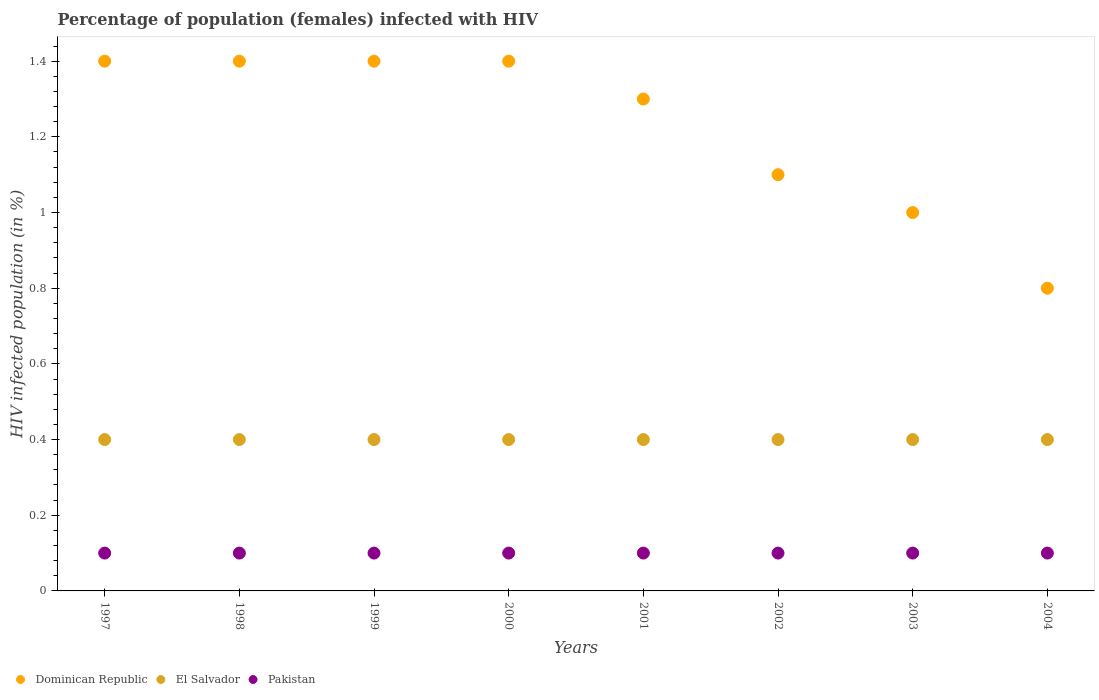How many different coloured dotlines are there?
Your response must be concise. 3. What is the percentage of HIV infected female population in Pakistan in 2000?
Provide a succinct answer. 0.1. Across all years, what is the maximum percentage of HIV infected female population in Pakistan?
Provide a succinct answer. 0.1. What is the total percentage of HIV infected female population in Pakistan in the graph?
Offer a very short reply. 0.8. What is the difference between the percentage of HIV infected female population in Dominican Republic in 1998 and that in 2001?
Provide a succinct answer. 0.1. What is the difference between the percentage of HIV infected female population in El Salvador in 1999 and the percentage of HIV infected female population in Dominican Republic in 2000?
Offer a terse response. -1. What is the average percentage of HIV infected female population in Dominican Republic per year?
Your response must be concise. 1.23. In the year 2003, what is the difference between the percentage of HIV infected female population in El Salvador and percentage of HIV infected female population in Pakistan?
Give a very brief answer. 0.3. What is the ratio of the percentage of HIV infected female population in Dominican Republic in 1998 to that in 2000?
Make the answer very short. 1. Is the percentage of HIV infected female population in Dominican Republic in 2001 less than that in 2002?
Your response must be concise. No. Is the difference between the percentage of HIV infected female population in El Salvador in 1999 and 2003 greater than the difference between the percentage of HIV infected female population in Pakistan in 1999 and 2003?
Provide a short and direct response. No. What is the difference between the highest and the second highest percentage of HIV infected female population in Pakistan?
Offer a very short reply. 0. What is the difference between the highest and the lowest percentage of HIV infected female population in Dominican Republic?
Give a very brief answer. 0.6. How many years are there in the graph?
Make the answer very short. 8. What is the difference between two consecutive major ticks on the Y-axis?
Your answer should be compact. 0.2. Does the graph contain any zero values?
Ensure brevity in your answer.  No. Does the graph contain grids?
Your response must be concise. No. Where does the legend appear in the graph?
Your response must be concise. Bottom left. How many legend labels are there?
Your response must be concise. 3. What is the title of the graph?
Offer a terse response. Percentage of population (females) infected with HIV. What is the label or title of the Y-axis?
Keep it short and to the point. HIV infected population (in %). What is the HIV infected population (in %) in El Salvador in 1997?
Provide a succinct answer. 0.4. What is the HIV infected population (in %) in Pakistan in 1997?
Give a very brief answer. 0.1. What is the HIV infected population (in %) in El Salvador in 1998?
Provide a succinct answer. 0.4. What is the HIV infected population (in %) of Pakistan in 1998?
Give a very brief answer. 0.1. What is the HIV infected population (in %) of El Salvador in 1999?
Make the answer very short. 0.4. What is the HIV infected population (in %) in Dominican Republic in 2000?
Provide a succinct answer. 1.4. What is the HIV infected population (in %) of Pakistan in 2000?
Provide a short and direct response. 0.1. What is the HIV infected population (in %) of Dominican Republic in 2002?
Offer a terse response. 1.1. What is the HIV infected population (in %) of El Salvador in 2002?
Your answer should be very brief. 0.4. What is the HIV infected population (in %) of Pakistan in 2002?
Make the answer very short. 0.1. What is the HIV infected population (in %) in Dominican Republic in 2003?
Your response must be concise. 1. What is the HIV infected population (in %) of Dominican Republic in 2004?
Your answer should be compact. 0.8. Across all years, what is the maximum HIV infected population (in %) in Dominican Republic?
Offer a terse response. 1.4. Across all years, what is the maximum HIV infected population (in %) of Pakistan?
Your response must be concise. 0.1. Across all years, what is the minimum HIV infected population (in %) of Dominican Republic?
Provide a succinct answer. 0.8. Across all years, what is the minimum HIV infected population (in %) of El Salvador?
Provide a succinct answer. 0.4. What is the total HIV infected population (in %) of Dominican Republic in the graph?
Provide a short and direct response. 9.8. What is the difference between the HIV infected population (in %) in Dominican Republic in 1997 and that in 1999?
Offer a terse response. 0. What is the difference between the HIV infected population (in %) in Dominican Republic in 1997 and that in 2000?
Offer a terse response. 0. What is the difference between the HIV infected population (in %) of Dominican Republic in 1997 and that in 2001?
Ensure brevity in your answer.  0.1. What is the difference between the HIV infected population (in %) in El Salvador in 1997 and that in 2001?
Keep it short and to the point. 0. What is the difference between the HIV infected population (in %) of Pakistan in 1997 and that in 2001?
Make the answer very short. 0. What is the difference between the HIV infected population (in %) of El Salvador in 1997 and that in 2002?
Your answer should be very brief. 0. What is the difference between the HIV infected population (in %) of El Salvador in 1997 and that in 2003?
Make the answer very short. 0. What is the difference between the HIV infected population (in %) in Pakistan in 1997 and that in 2003?
Your answer should be very brief. 0. What is the difference between the HIV infected population (in %) in Dominican Republic in 1997 and that in 2004?
Provide a succinct answer. 0.6. What is the difference between the HIV infected population (in %) of El Salvador in 1997 and that in 2004?
Offer a terse response. 0. What is the difference between the HIV infected population (in %) in El Salvador in 1998 and that in 1999?
Give a very brief answer. 0. What is the difference between the HIV infected population (in %) in Pakistan in 1998 and that in 1999?
Make the answer very short. 0. What is the difference between the HIV infected population (in %) of El Salvador in 1998 and that in 2000?
Make the answer very short. 0. What is the difference between the HIV infected population (in %) of Pakistan in 1998 and that in 2000?
Offer a terse response. 0. What is the difference between the HIV infected population (in %) of Pakistan in 1998 and that in 2001?
Offer a very short reply. 0. What is the difference between the HIV infected population (in %) of Dominican Republic in 1998 and that in 2002?
Provide a succinct answer. 0.3. What is the difference between the HIV infected population (in %) of El Salvador in 1998 and that in 2002?
Keep it short and to the point. 0. What is the difference between the HIV infected population (in %) of Dominican Republic in 1998 and that in 2003?
Offer a terse response. 0.4. What is the difference between the HIV infected population (in %) in El Salvador in 1998 and that in 2003?
Make the answer very short. 0. What is the difference between the HIV infected population (in %) in Pakistan in 1998 and that in 2003?
Your answer should be compact. 0. What is the difference between the HIV infected population (in %) in El Salvador in 1998 and that in 2004?
Keep it short and to the point. 0. What is the difference between the HIV infected population (in %) of Pakistan in 1998 and that in 2004?
Offer a very short reply. 0. What is the difference between the HIV infected population (in %) in Dominican Republic in 1999 and that in 2000?
Make the answer very short. 0. What is the difference between the HIV infected population (in %) in Pakistan in 1999 and that in 2000?
Your response must be concise. 0. What is the difference between the HIV infected population (in %) in Dominican Republic in 1999 and that in 2001?
Offer a terse response. 0.1. What is the difference between the HIV infected population (in %) in El Salvador in 1999 and that in 2001?
Your answer should be very brief. 0. What is the difference between the HIV infected population (in %) in Dominican Republic in 1999 and that in 2003?
Offer a very short reply. 0.4. What is the difference between the HIV infected population (in %) in Pakistan in 1999 and that in 2003?
Make the answer very short. 0. What is the difference between the HIV infected population (in %) in Pakistan in 1999 and that in 2004?
Provide a succinct answer. 0. What is the difference between the HIV infected population (in %) in Dominican Republic in 2000 and that in 2001?
Provide a short and direct response. 0.1. What is the difference between the HIV infected population (in %) in Dominican Republic in 2000 and that in 2002?
Provide a succinct answer. 0.3. What is the difference between the HIV infected population (in %) of El Salvador in 2000 and that in 2002?
Keep it short and to the point. 0. What is the difference between the HIV infected population (in %) in El Salvador in 2000 and that in 2003?
Make the answer very short. 0. What is the difference between the HIV infected population (in %) in Pakistan in 2000 and that in 2003?
Your answer should be very brief. 0. What is the difference between the HIV infected population (in %) of Dominican Republic in 2000 and that in 2004?
Offer a terse response. 0.6. What is the difference between the HIV infected population (in %) of Pakistan in 2000 and that in 2004?
Your response must be concise. 0. What is the difference between the HIV infected population (in %) of Dominican Republic in 2001 and that in 2002?
Keep it short and to the point. 0.2. What is the difference between the HIV infected population (in %) in El Salvador in 2001 and that in 2003?
Make the answer very short. 0. What is the difference between the HIV infected population (in %) in Dominican Republic in 2001 and that in 2004?
Ensure brevity in your answer.  0.5. What is the difference between the HIV infected population (in %) of El Salvador in 2001 and that in 2004?
Your answer should be very brief. 0. What is the difference between the HIV infected population (in %) in Dominican Republic in 2002 and that in 2003?
Your response must be concise. 0.1. What is the difference between the HIV infected population (in %) in El Salvador in 2002 and that in 2003?
Offer a very short reply. 0. What is the difference between the HIV infected population (in %) in Pakistan in 2002 and that in 2003?
Offer a very short reply. 0. What is the difference between the HIV infected population (in %) in Dominican Republic in 2003 and that in 2004?
Make the answer very short. 0.2. What is the difference between the HIV infected population (in %) in El Salvador in 2003 and that in 2004?
Your response must be concise. 0. What is the difference between the HIV infected population (in %) of Pakistan in 2003 and that in 2004?
Provide a succinct answer. 0. What is the difference between the HIV infected population (in %) of Dominican Republic in 1997 and the HIV infected population (in %) of El Salvador in 1998?
Keep it short and to the point. 1. What is the difference between the HIV infected population (in %) in Dominican Republic in 1997 and the HIV infected population (in %) in Pakistan in 1998?
Provide a succinct answer. 1.3. What is the difference between the HIV infected population (in %) of Dominican Republic in 1997 and the HIV infected population (in %) of El Salvador in 1999?
Your answer should be very brief. 1. What is the difference between the HIV infected population (in %) of Dominican Republic in 1997 and the HIV infected population (in %) of Pakistan in 1999?
Your response must be concise. 1.3. What is the difference between the HIV infected population (in %) of El Salvador in 1997 and the HIV infected population (in %) of Pakistan in 2000?
Your response must be concise. 0.3. What is the difference between the HIV infected population (in %) in Dominican Republic in 1997 and the HIV infected population (in %) in El Salvador in 2001?
Your answer should be very brief. 1. What is the difference between the HIV infected population (in %) in Dominican Republic in 1997 and the HIV infected population (in %) in Pakistan in 2001?
Keep it short and to the point. 1.3. What is the difference between the HIV infected population (in %) of El Salvador in 1997 and the HIV infected population (in %) of Pakistan in 2001?
Ensure brevity in your answer.  0.3. What is the difference between the HIV infected population (in %) of Dominican Republic in 1997 and the HIV infected population (in %) of El Salvador in 2002?
Your answer should be compact. 1. What is the difference between the HIV infected population (in %) of El Salvador in 1997 and the HIV infected population (in %) of Pakistan in 2002?
Your answer should be compact. 0.3. What is the difference between the HIV infected population (in %) in Dominican Republic in 1997 and the HIV infected population (in %) in El Salvador in 2003?
Ensure brevity in your answer.  1. What is the difference between the HIV infected population (in %) of El Salvador in 1997 and the HIV infected population (in %) of Pakistan in 2003?
Your answer should be very brief. 0.3. What is the difference between the HIV infected population (in %) of Dominican Republic in 1997 and the HIV infected population (in %) of Pakistan in 2004?
Offer a terse response. 1.3. What is the difference between the HIV infected population (in %) in El Salvador in 1997 and the HIV infected population (in %) in Pakistan in 2004?
Your answer should be very brief. 0.3. What is the difference between the HIV infected population (in %) of Dominican Republic in 1998 and the HIV infected population (in %) of Pakistan in 2001?
Keep it short and to the point. 1.3. What is the difference between the HIV infected population (in %) of Dominican Republic in 1998 and the HIV infected population (in %) of El Salvador in 2002?
Give a very brief answer. 1. What is the difference between the HIV infected population (in %) of Dominican Republic in 1998 and the HIV infected population (in %) of Pakistan in 2002?
Keep it short and to the point. 1.3. What is the difference between the HIV infected population (in %) of Dominican Republic in 1998 and the HIV infected population (in %) of El Salvador in 2003?
Ensure brevity in your answer.  1. What is the difference between the HIV infected population (in %) of El Salvador in 1998 and the HIV infected population (in %) of Pakistan in 2003?
Your response must be concise. 0.3. What is the difference between the HIV infected population (in %) in El Salvador in 1998 and the HIV infected population (in %) in Pakistan in 2004?
Provide a short and direct response. 0.3. What is the difference between the HIV infected population (in %) in Dominican Republic in 1999 and the HIV infected population (in %) in El Salvador in 2000?
Keep it short and to the point. 1. What is the difference between the HIV infected population (in %) in Dominican Republic in 1999 and the HIV infected population (in %) in El Salvador in 2001?
Provide a succinct answer. 1. What is the difference between the HIV infected population (in %) of Dominican Republic in 1999 and the HIV infected population (in %) of Pakistan in 2001?
Your answer should be very brief. 1.3. What is the difference between the HIV infected population (in %) in El Salvador in 1999 and the HIV infected population (in %) in Pakistan in 2001?
Give a very brief answer. 0.3. What is the difference between the HIV infected population (in %) of Dominican Republic in 1999 and the HIV infected population (in %) of El Salvador in 2002?
Provide a succinct answer. 1. What is the difference between the HIV infected population (in %) in El Salvador in 1999 and the HIV infected population (in %) in Pakistan in 2002?
Offer a very short reply. 0.3. What is the difference between the HIV infected population (in %) in El Salvador in 1999 and the HIV infected population (in %) in Pakistan in 2003?
Your answer should be very brief. 0.3. What is the difference between the HIV infected population (in %) of Dominican Republic in 1999 and the HIV infected population (in %) of El Salvador in 2004?
Your answer should be very brief. 1. What is the difference between the HIV infected population (in %) in El Salvador in 1999 and the HIV infected population (in %) in Pakistan in 2004?
Provide a succinct answer. 0.3. What is the difference between the HIV infected population (in %) of El Salvador in 2000 and the HIV infected population (in %) of Pakistan in 2001?
Offer a very short reply. 0.3. What is the difference between the HIV infected population (in %) of Dominican Republic in 2000 and the HIV infected population (in %) of El Salvador in 2002?
Give a very brief answer. 1. What is the difference between the HIV infected population (in %) in Dominican Republic in 2000 and the HIV infected population (in %) in Pakistan in 2002?
Your answer should be compact. 1.3. What is the difference between the HIV infected population (in %) of Dominican Republic in 2000 and the HIV infected population (in %) of El Salvador in 2003?
Give a very brief answer. 1. What is the difference between the HIV infected population (in %) of El Salvador in 2000 and the HIV infected population (in %) of Pakistan in 2003?
Your answer should be very brief. 0.3. What is the difference between the HIV infected population (in %) in Dominican Republic in 2000 and the HIV infected population (in %) in El Salvador in 2004?
Provide a succinct answer. 1. What is the difference between the HIV infected population (in %) of Dominican Republic in 2000 and the HIV infected population (in %) of Pakistan in 2004?
Keep it short and to the point. 1.3. What is the difference between the HIV infected population (in %) of Dominican Republic in 2001 and the HIV infected population (in %) of Pakistan in 2002?
Your response must be concise. 1.2. What is the difference between the HIV infected population (in %) in El Salvador in 2001 and the HIV infected population (in %) in Pakistan in 2002?
Ensure brevity in your answer.  0.3. What is the difference between the HIV infected population (in %) of Dominican Republic in 2001 and the HIV infected population (in %) of El Salvador in 2004?
Ensure brevity in your answer.  0.9. What is the difference between the HIV infected population (in %) of El Salvador in 2001 and the HIV infected population (in %) of Pakistan in 2004?
Make the answer very short. 0.3. What is the difference between the HIV infected population (in %) of Dominican Republic in 2002 and the HIV infected population (in %) of El Salvador in 2003?
Ensure brevity in your answer.  0.7. What is the difference between the HIV infected population (in %) of Dominican Republic in 2002 and the HIV infected population (in %) of Pakistan in 2003?
Give a very brief answer. 1. What is the difference between the HIV infected population (in %) of El Salvador in 2002 and the HIV infected population (in %) of Pakistan in 2004?
Give a very brief answer. 0.3. What is the difference between the HIV infected population (in %) of El Salvador in 2003 and the HIV infected population (in %) of Pakistan in 2004?
Ensure brevity in your answer.  0.3. What is the average HIV infected population (in %) of Dominican Republic per year?
Make the answer very short. 1.23. What is the average HIV infected population (in %) in El Salvador per year?
Offer a very short reply. 0.4. In the year 1997, what is the difference between the HIV infected population (in %) in Dominican Republic and HIV infected population (in %) in Pakistan?
Offer a very short reply. 1.3. In the year 1998, what is the difference between the HIV infected population (in %) of Dominican Republic and HIV infected population (in %) of El Salvador?
Offer a terse response. 1. In the year 1998, what is the difference between the HIV infected population (in %) in Dominican Republic and HIV infected population (in %) in Pakistan?
Your response must be concise. 1.3. In the year 1998, what is the difference between the HIV infected population (in %) of El Salvador and HIV infected population (in %) of Pakistan?
Make the answer very short. 0.3. In the year 1999, what is the difference between the HIV infected population (in %) of Dominican Republic and HIV infected population (in %) of Pakistan?
Offer a terse response. 1.3. In the year 1999, what is the difference between the HIV infected population (in %) in El Salvador and HIV infected population (in %) in Pakistan?
Provide a short and direct response. 0.3. In the year 2000, what is the difference between the HIV infected population (in %) of Dominican Republic and HIV infected population (in %) of Pakistan?
Keep it short and to the point. 1.3. In the year 2000, what is the difference between the HIV infected population (in %) of El Salvador and HIV infected population (in %) of Pakistan?
Ensure brevity in your answer.  0.3. In the year 2001, what is the difference between the HIV infected population (in %) of Dominican Republic and HIV infected population (in %) of El Salvador?
Provide a succinct answer. 0.9. In the year 2001, what is the difference between the HIV infected population (in %) in El Salvador and HIV infected population (in %) in Pakistan?
Offer a terse response. 0.3. In the year 2002, what is the difference between the HIV infected population (in %) in Dominican Republic and HIV infected population (in %) in El Salvador?
Keep it short and to the point. 0.7. In the year 2002, what is the difference between the HIV infected population (in %) of El Salvador and HIV infected population (in %) of Pakistan?
Keep it short and to the point. 0.3. In the year 2003, what is the difference between the HIV infected population (in %) of El Salvador and HIV infected population (in %) of Pakistan?
Provide a succinct answer. 0.3. In the year 2004, what is the difference between the HIV infected population (in %) of Dominican Republic and HIV infected population (in %) of El Salvador?
Provide a succinct answer. 0.4. In the year 2004, what is the difference between the HIV infected population (in %) in El Salvador and HIV infected population (in %) in Pakistan?
Keep it short and to the point. 0.3. What is the ratio of the HIV infected population (in %) of El Salvador in 1997 to that in 1998?
Make the answer very short. 1. What is the ratio of the HIV infected population (in %) in Dominican Republic in 1997 to that in 1999?
Give a very brief answer. 1. What is the ratio of the HIV infected population (in %) of Pakistan in 1997 to that in 1999?
Make the answer very short. 1. What is the ratio of the HIV infected population (in %) in El Salvador in 1997 to that in 2001?
Your response must be concise. 1. What is the ratio of the HIV infected population (in %) in Pakistan in 1997 to that in 2001?
Offer a very short reply. 1. What is the ratio of the HIV infected population (in %) of Dominican Republic in 1997 to that in 2002?
Provide a succinct answer. 1.27. What is the ratio of the HIV infected population (in %) in El Salvador in 1997 to that in 2002?
Offer a terse response. 1. What is the ratio of the HIV infected population (in %) in Pakistan in 1997 to that in 2002?
Make the answer very short. 1. What is the ratio of the HIV infected population (in %) of Dominican Republic in 1997 to that in 2003?
Provide a succinct answer. 1.4. What is the ratio of the HIV infected population (in %) in Dominican Republic in 1997 to that in 2004?
Your response must be concise. 1.75. What is the ratio of the HIV infected population (in %) of Pakistan in 1997 to that in 2004?
Your response must be concise. 1. What is the ratio of the HIV infected population (in %) in Dominican Republic in 1998 to that in 1999?
Offer a very short reply. 1. What is the ratio of the HIV infected population (in %) of El Salvador in 1998 to that in 1999?
Provide a short and direct response. 1. What is the ratio of the HIV infected population (in %) of Pakistan in 1998 to that in 1999?
Provide a succinct answer. 1. What is the ratio of the HIV infected population (in %) of Dominican Republic in 1998 to that in 2000?
Ensure brevity in your answer.  1. What is the ratio of the HIV infected population (in %) of El Salvador in 1998 to that in 2000?
Your answer should be compact. 1. What is the ratio of the HIV infected population (in %) in Pakistan in 1998 to that in 2000?
Provide a short and direct response. 1. What is the ratio of the HIV infected population (in %) in Dominican Republic in 1998 to that in 2002?
Offer a terse response. 1.27. What is the ratio of the HIV infected population (in %) of El Salvador in 1998 to that in 2002?
Offer a very short reply. 1. What is the ratio of the HIV infected population (in %) in Pakistan in 1998 to that in 2002?
Your response must be concise. 1. What is the ratio of the HIV infected population (in %) in Dominican Republic in 1998 to that in 2003?
Keep it short and to the point. 1.4. What is the ratio of the HIV infected population (in %) in Pakistan in 1998 to that in 2003?
Keep it short and to the point. 1. What is the ratio of the HIV infected population (in %) of El Salvador in 1998 to that in 2004?
Provide a short and direct response. 1. What is the ratio of the HIV infected population (in %) in Pakistan in 1998 to that in 2004?
Ensure brevity in your answer.  1. What is the ratio of the HIV infected population (in %) in Dominican Republic in 1999 to that in 2000?
Provide a short and direct response. 1. What is the ratio of the HIV infected population (in %) of Pakistan in 1999 to that in 2000?
Offer a very short reply. 1. What is the ratio of the HIV infected population (in %) in Pakistan in 1999 to that in 2001?
Give a very brief answer. 1. What is the ratio of the HIV infected population (in %) of Dominican Republic in 1999 to that in 2002?
Give a very brief answer. 1.27. What is the ratio of the HIV infected population (in %) in El Salvador in 1999 to that in 2002?
Make the answer very short. 1. What is the ratio of the HIV infected population (in %) in Dominican Republic in 1999 to that in 2003?
Provide a succinct answer. 1.4. What is the ratio of the HIV infected population (in %) in El Salvador in 1999 to that in 2003?
Offer a terse response. 1. What is the ratio of the HIV infected population (in %) of Dominican Republic in 1999 to that in 2004?
Provide a succinct answer. 1.75. What is the ratio of the HIV infected population (in %) in El Salvador in 1999 to that in 2004?
Your answer should be very brief. 1. What is the ratio of the HIV infected population (in %) of Pakistan in 1999 to that in 2004?
Your answer should be very brief. 1. What is the ratio of the HIV infected population (in %) of Dominican Republic in 2000 to that in 2001?
Offer a very short reply. 1.08. What is the ratio of the HIV infected population (in %) of El Salvador in 2000 to that in 2001?
Provide a succinct answer. 1. What is the ratio of the HIV infected population (in %) in Pakistan in 2000 to that in 2001?
Provide a succinct answer. 1. What is the ratio of the HIV infected population (in %) in Dominican Republic in 2000 to that in 2002?
Offer a very short reply. 1.27. What is the ratio of the HIV infected population (in %) in El Salvador in 2000 to that in 2002?
Provide a succinct answer. 1. What is the ratio of the HIV infected population (in %) of Dominican Republic in 2000 to that in 2004?
Ensure brevity in your answer.  1.75. What is the ratio of the HIV infected population (in %) in El Salvador in 2000 to that in 2004?
Keep it short and to the point. 1. What is the ratio of the HIV infected population (in %) in Pakistan in 2000 to that in 2004?
Your response must be concise. 1. What is the ratio of the HIV infected population (in %) in Dominican Republic in 2001 to that in 2002?
Offer a very short reply. 1.18. What is the ratio of the HIV infected population (in %) in El Salvador in 2001 to that in 2002?
Offer a terse response. 1. What is the ratio of the HIV infected population (in %) of El Salvador in 2001 to that in 2003?
Give a very brief answer. 1. What is the ratio of the HIV infected population (in %) of Dominican Republic in 2001 to that in 2004?
Offer a terse response. 1.62. What is the ratio of the HIV infected population (in %) of El Salvador in 2001 to that in 2004?
Offer a very short reply. 1. What is the ratio of the HIV infected population (in %) of Dominican Republic in 2002 to that in 2004?
Ensure brevity in your answer.  1.38. What is the ratio of the HIV infected population (in %) in El Salvador in 2002 to that in 2004?
Provide a succinct answer. 1. What is the ratio of the HIV infected population (in %) of Pakistan in 2002 to that in 2004?
Ensure brevity in your answer.  1. What is the ratio of the HIV infected population (in %) in Pakistan in 2003 to that in 2004?
Provide a short and direct response. 1. What is the difference between the highest and the second highest HIV infected population (in %) in Dominican Republic?
Your answer should be very brief. 0. What is the difference between the highest and the second highest HIV infected population (in %) of Pakistan?
Provide a short and direct response. 0. 